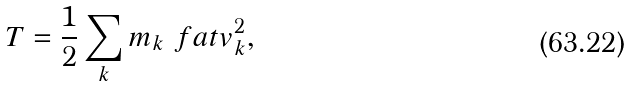Convert formula to latex. <formula><loc_0><loc_0><loc_500><loc_500>T = \frac { 1 } { 2 } \sum _ { k } m _ { k } \ f a t v _ { k } ^ { 2 } ,</formula> 